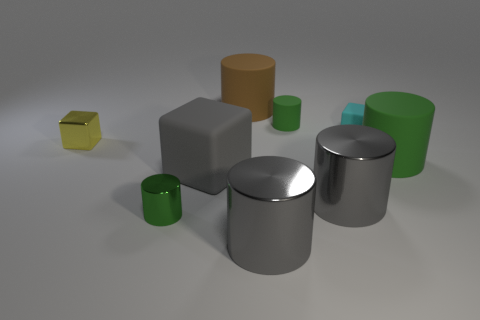Is the number of tiny green metal things less than the number of large metal objects?
Keep it short and to the point. Yes. There is a rubber cube behind the metallic block; how big is it?
Ensure brevity in your answer.  Small. The thing that is both behind the big green cylinder and left of the big brown rubber cylinder has what shape?
Offer a very short reply. Cube. The cyan matte object that is the same shape as the tiny yellow shiny object is what size?
Ensure brevity in your answer.  Small. How many gray cubes have the same material as the brown cylinder?
Your answer should be compact. 1. Do the metal block and the large rubber thing in front of the big green matte object have the same color?
Your answer should be very brief. No. Are there more tiny yellow cubes than big metallic cylinders?
Give a very brief answer. No. The large rubber block is what color?
Offer a very short reply. Gray. Does the matte cylinder in front of the shiny block have the same color as the small rubber cylinder?
Your answer should be very brief. Yes. There is another tiny cylinder that is the same color as the tiny matte cylinder; what is it made of?
Give a very brief answer. Metal. 